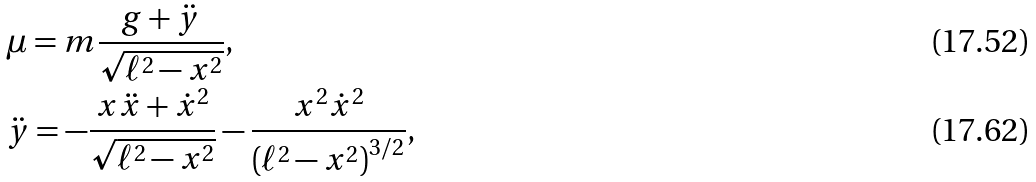Convert formula to latex. <formula><loc_0><loc_0><loc_500><loc_500>& \mu = m \frac { g + \ddot { y } } { \sqrt { \ell ^ { 2 } - x ^ { 2 } } } , \\ & \ddot { y } = - \frac { x \ddot { x } + \dot { x } ^ { 2 } } { \sqrt { \ell ^ { 2 } - x ^ { 2 } } } - \frac { x ^ { 2 } \dot { x } ^ { 2 } } { \left ( \ell ^ { 2 } - x ^ { 2 } \right ) ^ { 3 / 2 } } ,</formula> 